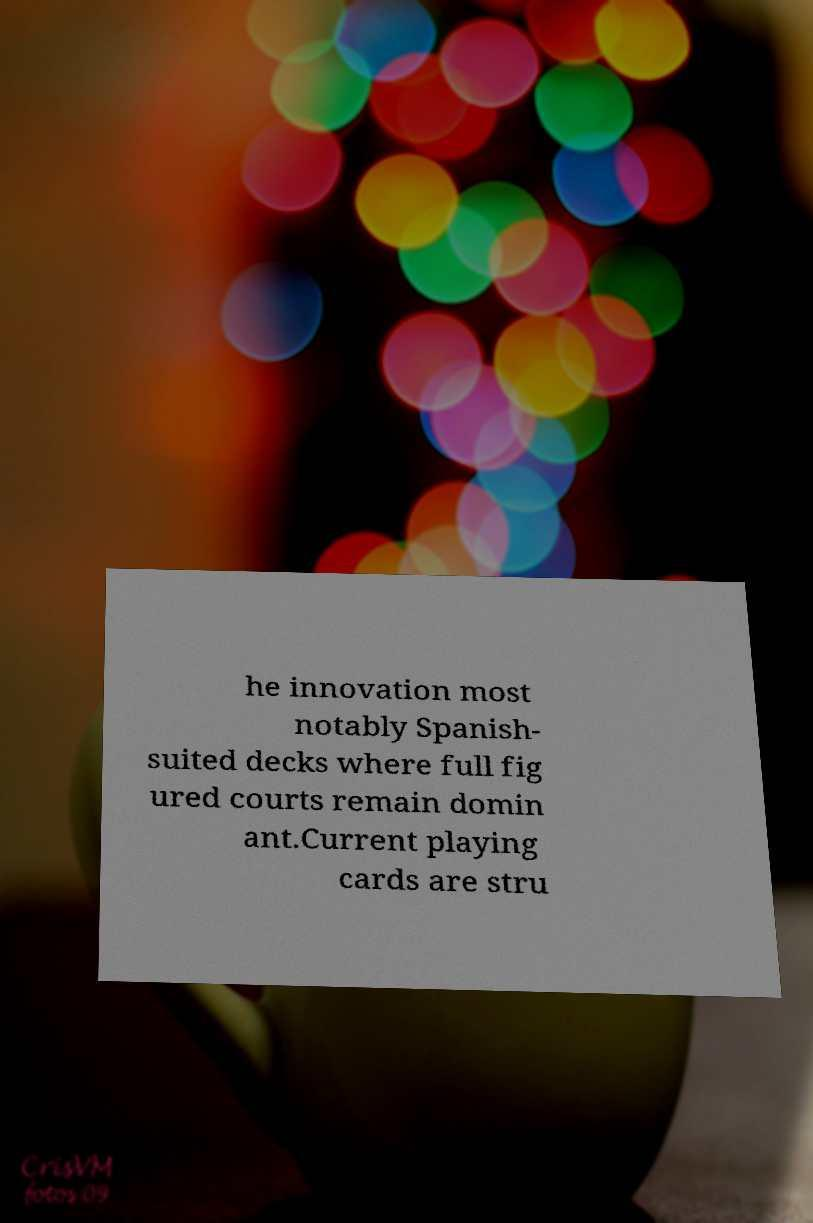Can you accurately transcribe the text from the provided image for me? he innovation most notably Spanish- suited decks where full fig ured courts remain domin ant.Current playing cards are stru 